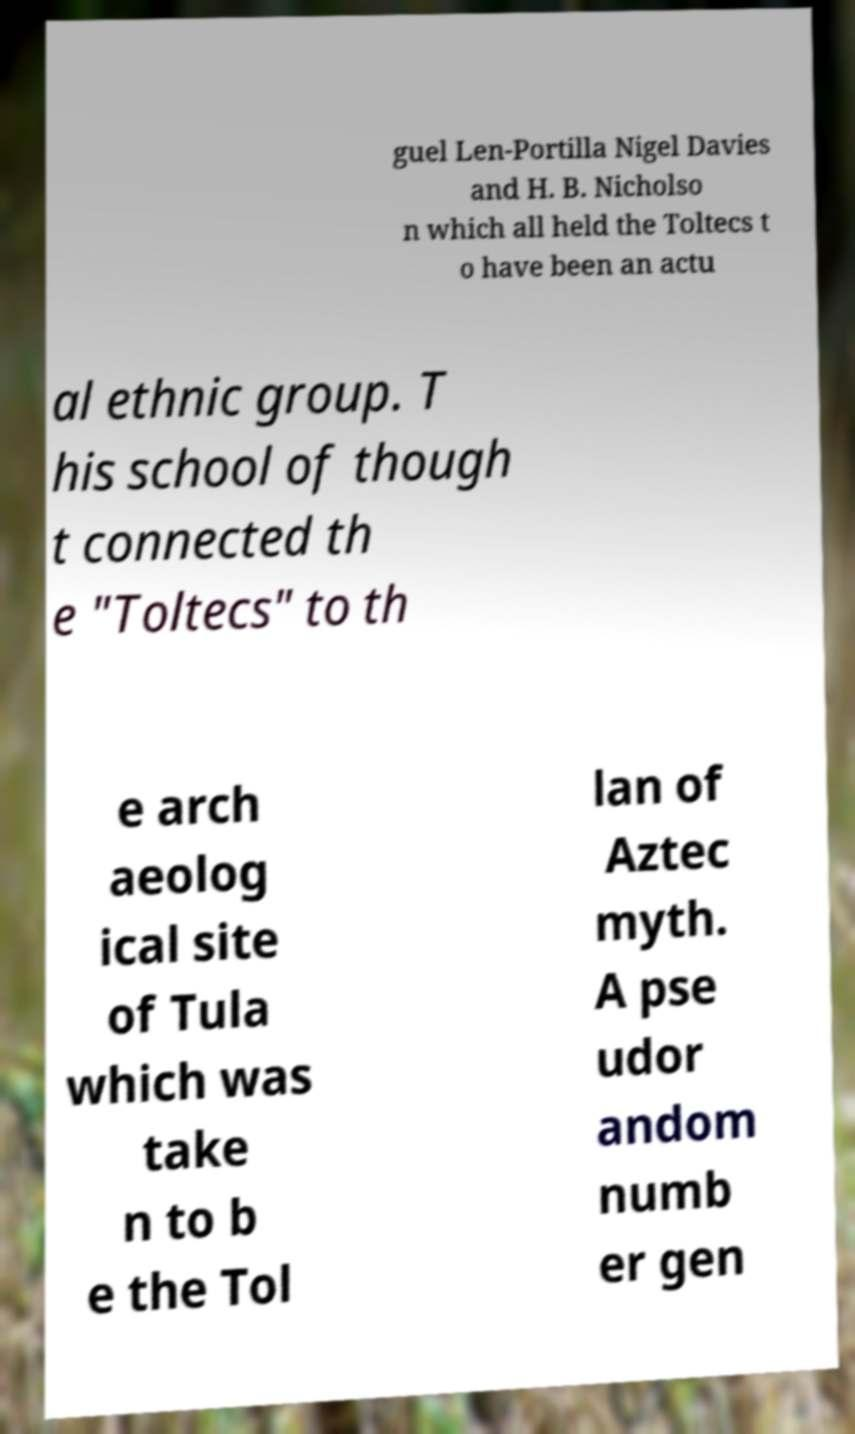Please identify and transcribe the text found in this image. guel Len-Portilla Nigel Davies and H. B. Nicholso n which all held the Toltecs t o have been an actu al ethnic group. T his school of though t connected th e "Toltecs" to th e arch aeolog ical site of Tula which was take n to b e the Tol lan of Aztec myth. A pse udor andom numb er gen 